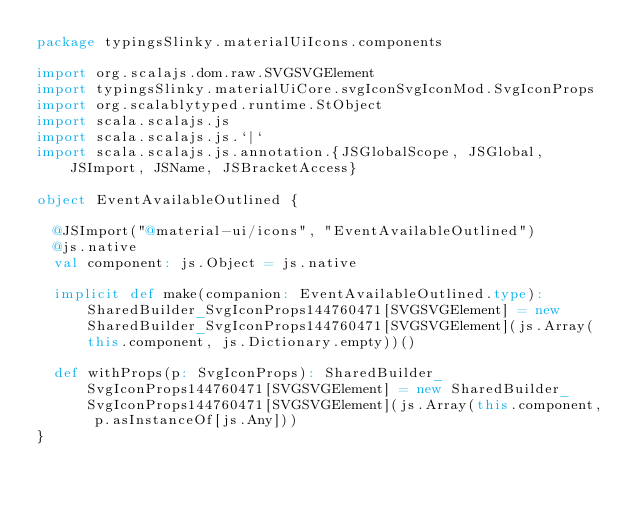Convert code to text. <code><loc_0><loc_0><loc_500><loc_500><_Scala_>package typingsSlinky.materialUiIcons.components

import org.scalajs.dom.raw.SVGSVGElement
import typingsSlinky.materialUiCore.svgIconSvgIconMod.SvgIconProps
import org.scalablytyped.runtime.StObject
import scala.scalajs.js
import scala.scalajs.js.`|`
import scala.scalajs.js.annotation.{JSGlobalScope, JSGlobal, JSImport, JSName, JSBracketAccess}

object EventAvailableOutlined {
  
  @JSImport("@material-ui/icons", "EventAvailableOutlined")
  @js.native
  val component: js.Object = js.native
  
  implicit def make(companion: EventAvailableOutlined.type): SharedBuilder_SvgIconProps144760471[SVGSVGElement] = new SharedBuilder_SvgIconProps144760471[SVGSVGElement](js.Array(this.component, js.Dictionary.empty))()
  
  def withProps(p: SvgIconProps): SharedBuilder_SvgIconProps144760471[SVGSVGElement] = new SharedBuilder_SvgIconProps144760471[SVGSVGElement](js.Array(this.component, p.asInstanceOf[js.Any]))
}
</code> 